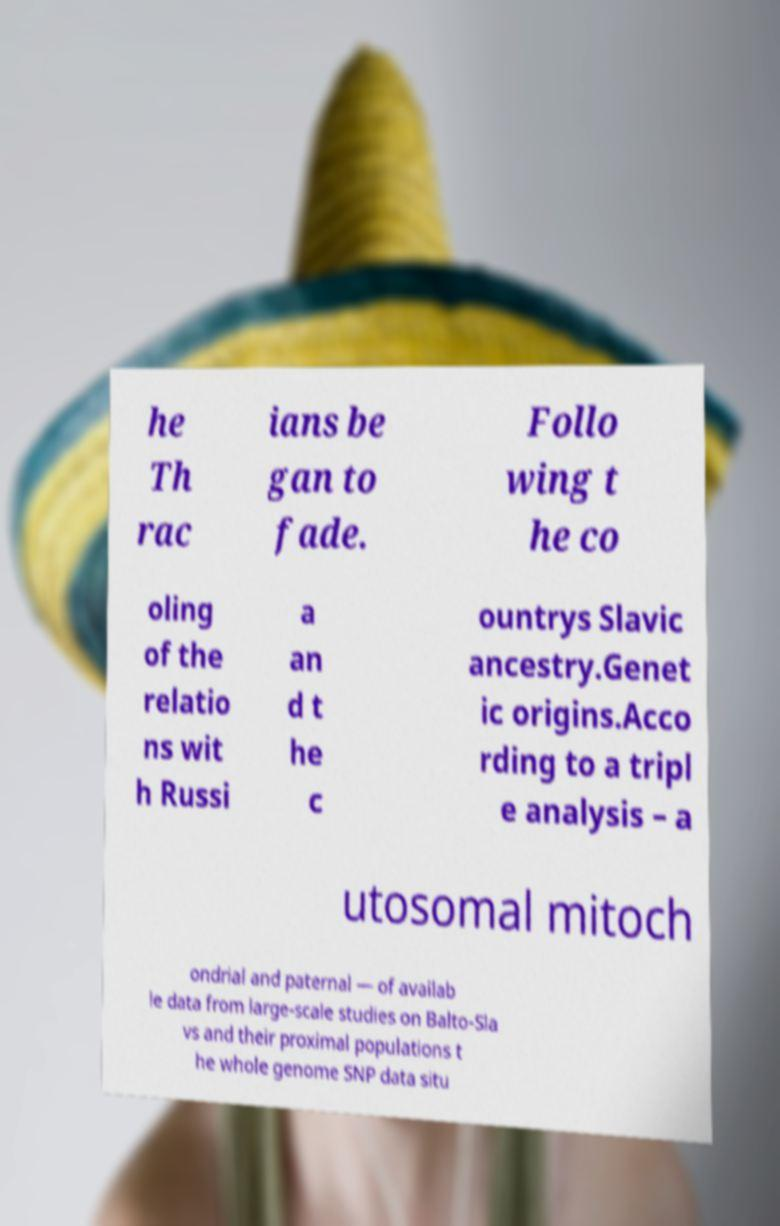Can you read and provide the text displayed in the image?This photo seems to have some interesting text. Can you extract and type it out for me? he Th rac ians be gan to fade. Follo wing t he co oling of the relatio ns wit h Russi a an d t he c ountrys Slavic ancestry.Genet ic origins.Acco rding to a tripl e analysis – a utosomal mitoch ondrial and paternal — of availab le data from large-scale studies on Balto-Sla vs and their proximal populations t he whole genome SNP data situ 